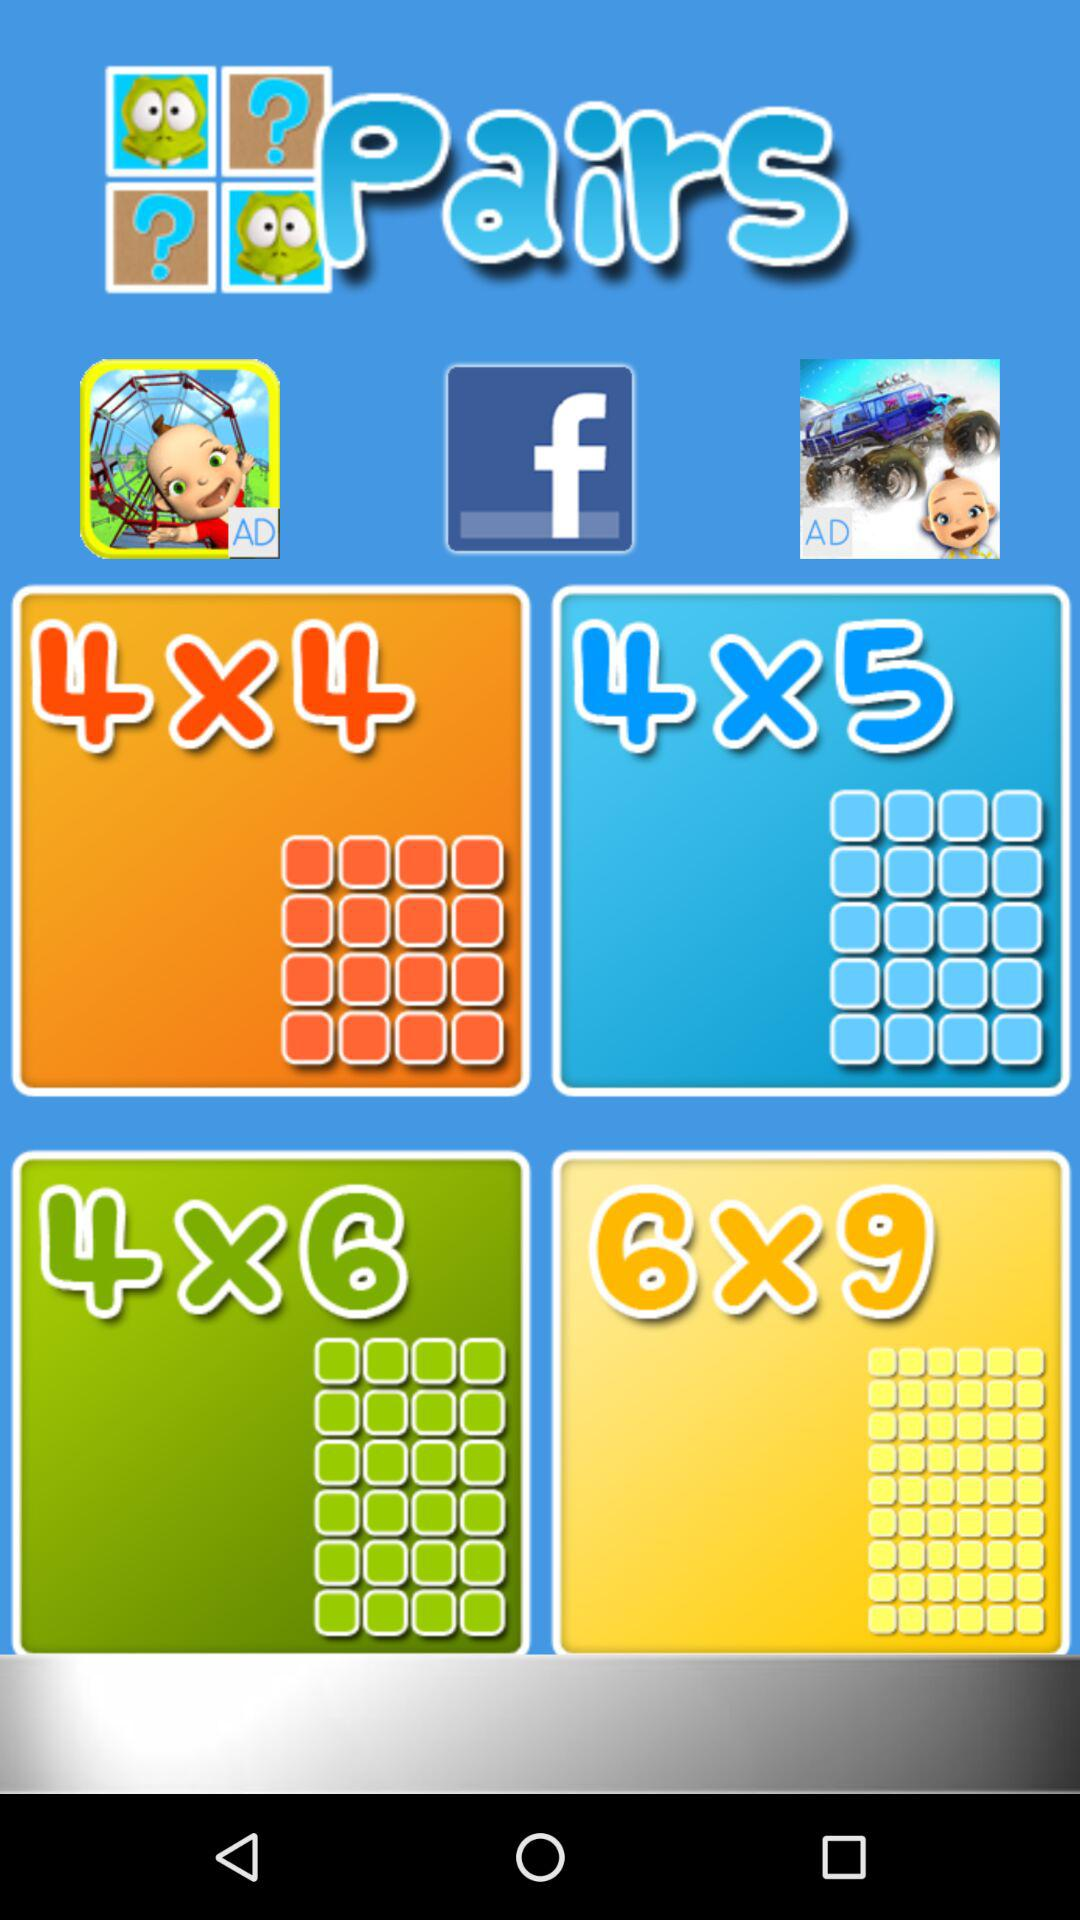What is the application that can be used to connect? The application that can be used to connect is "Facebook". 